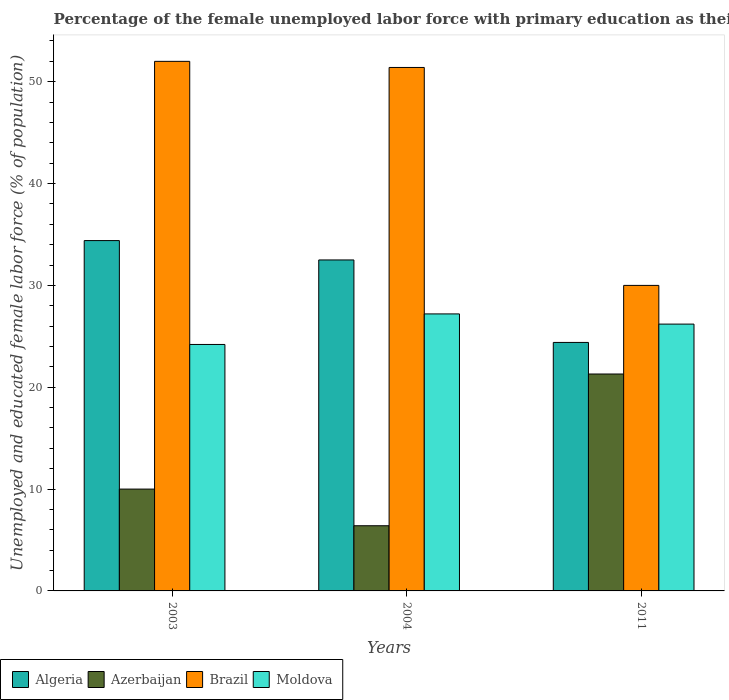How many different coloured bars are there?
Offer a terse response. 4. How many groups of bars are there?
Keep it short and to the point. 3. Are the number of bars on each tick of the X-axis equal?
Keep it short and to the point. Yes. How many bars are there on the 3rd tick from the left?
Your answer should be compact. 4. How many bars are there on the 1st tick from the right?
Provide a succinct answer. 4. What is the percentage of the unemployed female labor force with primary education in Algeria in 2004?
Keep it short and to the point. 32.5. Across all years, what is the maximum percentage of the unemployed female labor force with primary education in Moldova?
Your answer should be compact. 27.2. Across all years, what is the minimum percentage of the unemployed female labor force with primary education in Azerbaijan?
Provide a succinct answer. 6.4. What is the total percentage of the unemployed female labor force with primary education in Algeria in the graph?
Your answer should be compact. 91.3. What is the difference between the percentage of the unemployed female labor force with primary education in Brazil in 2004 and that in 2011?
Offer a very short reply. 21.4. What is the difference between the percentage of the unemployed female labor force with primary education in Brazil in 2003 and the percentage of the unemployed female labor force with primary education in Azerbaijan in 2004?
Provide a short and direct response. 45.6. What is the average percentage of the unemployed female labor force with primary education in Brazil per year?
Give a very brief answer. 44.47. In the year 2004, what is the difference between the percentage of the unemployed female labor force with primary education in Brazil and percentage of the unemployed female labor force with primary education in Algeria?
Your response must be concise. 18.9. In how many years, is the percentage of the unemployed female labor force with primary education in Azerbaijan greater than 2 %?
Your response must be concise. 3. What is the ratio of the percentage of the unemployed female labor force with primary education in Brazil in 2003 to that in 2011?
Provide a succinct answer. 1.73. What is the difference between the highest and the lowest percentage of the unemployed female labor force with primary education in Algeria?
Make the answer very short. 10. Is the sum of the percentage of the unemployed female labor force with primary education in Algeria in 2004 and 2011 greater than the maximum percentage of the unemployed female labor force with primary education in Brazil across all years?
Provide a short and direct response. Yes. What does the 4th bar from the left in 2011 represents?
Your answer should be very brief. Moldova. What does the 3rd bar from the right in 2004 represents?
Your answer should be compact. Azerbaijan. Is it the case that in every year, the sum of the percentage of the unemployed female labor force with primary education in Azerbaijan and percentage of the unemployed female labor force with primary education in Brazil is greater than the percentage of the unemployed female labor force with primary education in Algeria?
Ensure brevity in your answer.  Yes. Are the values on the major ticks of Y-axis written in scientific E-notation?
Keep it short and to the point. No. Does the graph contain any zero values?
Provide a succinct answer. No. Does the graph contain grids?
Offer a terse response. No. What is the title of the graph?
Provide a short and direct response. Percentage of the female unemployed labor force with primary education as their highest grade. Does "Haiti" appear as one of the legend labels in the graph?
Provide a short and direct response. No. What is the label or title of the X-axis?
Give a very brief answer. Years. What is the label or title of the Y-axis?
Your answer should be compact. Unemployed and educated female labor force (% of population). What is the Unemployed and educated female labor force (% of population) of Algeria in 2003?
Offer a very short reply. 34.4. What is the Unemployed and educated female labor force (% of population) of Azerbaijan in 2003?
Your answer should be very brief. 10. What is the Unemployed and educated female labor force (% of population) in Moldova in 2003?
Offer a terse response. 24.2. What is the Unemployed and educated female labor force (% of population) of Algeria in 2004?
Your response must be concise. 32.5. What is the Unemployed and educated female labor force (% of population) in Azerbaijan in 2004?
Offer a very short reply. 6.4. What is the Unemployed and educated female labor force (% of population) in Brazil in 2004?
Your response must be concise. 51.4. What is the Unemployed and educated female labor force (% of population) in Moldova in 2004?
Your answer should be very brief. 27.2. What is the Unemployed and educated female labor force (% of population) of Algeria in 2011?
Your answer should be compact. 24.4. What is the Unemployed and educated female labor force (% of population) of Azerbaijan in 2011?
Offer a terse response. 21.3. What is the Unemployed and educated female labor force (% of population) in Moldova in 2011?
Offer a terse response. 26.2. Across all years, what is the maximum Unemployed and educated female labor force (% of population) of Algeria?
Offer a very short reply. 34.4. Across all years, what is the maximum Unemployed and educated female labor force (% of population) of Azerbaijan?
Make the answer very short. 21.3. Across all years, what is the maximum Unemployed and educated female labor force (% of population) of Moldova?
Ensure brevity in your answer.  27.2. Across all years, what is the minimum Unemployed and educated female labor force (% of population) in Algeria?
Ensure brevity in your answer.  24.4. Across all years, what is the minimum Unemployed and educated female labor force (% of population) in Azerbaijan?
Provide a succinct answer. 6.4. Across all years, what is the minimum Unemployed and educated female labor force (% of population) of Moldova?
Keep it short and to the point. 24.2. What is the total Unemployed and educated female labor force (% of population) in Algeria in the graph?
Your answer should be compact. 91.3. What is the total Unemployed and educated female labor force (% of population) in Azerbaijan in the graph?
Ensure brevity in your answer.  37.7. What is the total Unemployed and educated female labor force (% of population) of Brazil in the graph?
Keep it short and to the point. 133.4. What is the total Unemployed and educated female labor force (% of population) in Moldova in the graph?
Give a very brief answer. 77.6. What is the difference between the Unemployed and educated female labor force (% of population) in Algeria in 2003 and that in 2004?
Your response must be concise. 1.9. What is the difference between the Unemployed and educated female labor force (% of population) in Azerbaijan in 2003 and that in 2004?
Your answer should be very brief. 3.6. What is the difference between the Unemployed and educated female labor force (% of population) in Moldova in 2003 and that in 2004?
Ensure brevity in your answer.  -3. What is the difference between the Unemployed and educated female labor force (% of population) of Algeria in 2003 and that in 2011?
Make the answer very short. 10. What is the difference between the Unemployed and educated female labor force (% of population) of Moldova in 2003 and that in 2011?
Give a very brief answer. -2. What is the difference between the Unemployed and educated female labor force (% of population) in Azerbaijan in 2004 and that in 2011?
Make the answer very short. -14.9. What is the difference between the Unemployed and educated female labor force (% of population) in Brazil in 2004 and that in 2011?
Offer a terse response. 21.4. What is the difference between the Unemployed and educated female labor force (% of population) in Moldova in 2004 and that in 2011?
Your answer should be compact. 1. What is the difference between the Unemployed and educated female labor force (% of population) in Algeria in 2003 and the Unemployed and educated female labor force (% of population) in Brazil in 2004?
Give a very brief answer. -17. What is the difference between the Unemployed and educated female labor force (% of population) in Algeria in 2003 and the Unemployed and educated female labor force (% of population) in Moldova in 2004?
Provide a succinct answer. 7.2. What is the difference between the Unemployed and educated female labor force (% of population) of Azerbaijan in 2003 and the Unemployed and educated female labor force (% of population) of Brazil in 2004?
Keep it short and to the point. -41.4. What is the difference between the Unemployed and educated female labor force (% of population) in Azerbaijan in 2003 and the Unemployed and educated female labor force (% of population) in Moldova in 2004?
Provide a succinct answer. -17.2. What is the difference between the Unemployed and educated female labor force (% of population) in Brazil in 2003 and the Unemployed and educated female labor force (% of population) in Moldova in 2004?
Provide a succinct answer. 24.8. What is the difference between the Unemployed and educated female labor force (% of population) in Algeria in 2003 and the Unemployed and educated female labor force (% of population) in Moldova in 2011?
Make the answer very short. 8.2. What is the difference between the Unemployed and educated female labor force (% of population) in Azerbaijan in 2003 and the Unemployed and educated female labor force (% of population) in Moldova in 2011?
Your answer should be very brief. -16.2. What is the difference between the Unemployed and educated female labor force (% of population) in Brazil in 2003 and the Unemployed and educated female labor force (% of population) in Moldova in 2011?
Your answer should be very brief. 25.8. What is the difference between the Unemployed and educated female labor force (% of population) of Algeria in 2004 and the Unemployed and educated female labor force (% of population) of Brazil in 2011?
Your answer should be compact. 2.5. What is the difference between the Unemployed and educated female labor force (% of population) in Algeria in 2004 and the Unemployed and educated female labor force (% of population) in Moldova in 2011?
Offer a terse response. 6.3. What is the difference between the Unemployed and educated female labor force (% of population) of Azerbaijan in 2004 and the Unemployed and educated female labor force (% of population) of Brazil in 2011?
Ensure brevity in your answer.  -23.6. What is the difference between the Unemployed and educated female labor force (% of population) of Azerbaijan in 2004 and the Unemployed and educated female labor force (% of population) of Moldova in 2011?
Provide a short and direct response. -19.8. What is the difference between the Unemployed and educated female labor force (% of population) of Brazil in 2004 and the Unemployed and educated female labor force (% of population) of Moldova in 2011?
Offer a very short reply. 25.2. What is the average Unemployed and educated female labor force (% of population) in Algeria per year?
Provide a succinct answer. 30.43. What is the average Unemployed and educated female labor force (% of population) in Azerbaijan per year?
Offer a very short reply. 12.57. What is the average Unemployed and educated female labor force (% of population) in Brazil per year?
Your answer should be compact. 44.47. What is the average Unemployed and educated female labor force (% of population) of Moldova per year?
Provide a short and direct response. 25.87. In the year 2003, what is the difference between the Unemployed and educated female labor force (% of population) in Algeria and Unemployed and educated female labor force (% of population) in Azerbaijan?
Give a very brief answer. 24.4. In the year 2003, what is the difference between the Unemployed and educated female labor force (% of population) of Algeria and Unemployed and educated female labor force (% of population) of Brazil?
Your answer should be very brief. -17.6. In the year 2003, what is the difference between the Unemployed and educated female labor force (% of population) of Azerbaijan and Unemployed and educated female labor force (% of population) of Brazil?
Keep it short and to the point. -42. In the year 2003, what is the difference between the Unemployed and educated female labor force (% of population) in Azerbaijan and Unemployed and educated female labor force (% of population) in Moldova?
Ensure brevity in your answer.  -14.2. In the year 2003, what is the difference between the Unemployed and educated female labor force (% of population) in Brazil and Unemployed and educated female labor force (% of population) in Moldova?
Offer a terse response. 27.8. In the year 2004, what is the difference between the Unemployed and educated female labor force (% of population) of Algeria and Unemployed and educated female labor force (% of population) of Azerbaijan?
Your answer should be compact. 26.1. In the year 2004, what is the difference between the Unemployed and educated female labor force (% of population) in Algeria and Unemployed and educated female labor force (% of population) in Brazil?
Provide a short and direct response. -18.9. In the year 2004, what is the difference between the Unemployed and educated female labor force (% of population) of Algeria and Unemployed and educated female labor force (% of population) of Moldova?
Your response must be concise. 5.3. In the year 2004, what is the difference between the Unemployed and educated female labor force (% of population) in Azerbaijan and Unemployed and educated female labor force (% of population) in Brazil?
Provide a short and direct response. -45. In the year 2004, what is the difference between the Unemployed and educated female labor force (% of population) of Azerbaijan and Unemployed and educated female labor force (% of population) of Moldova?
Ensure brevity in your answer.  -20.8. In the year 2004, what is the difference between the Unemployed and educated female labor force (% of population) of Brazil and Unemployed and educated female labor force (% of population) of Moldova?
Your answer should be compact. 24.2. In the year 2011, what is the difference between the Unemployed and educated female labor force (% of population) of Algeria and Unemployed and educated female labor force (% of population) of Brazil?
Ensure brevity in your answer.  -5.6. In the year 2011, what is the difference between the Unemployed and educated female labor force (% of population) of Algeria and Unemployed and educated female labor force (% of population) of Moldova?
Offer a very short reply. -1.8. In the year 2011, what is the difference between the Unemployed and educated female labor force (% of population) in Azerbaijan and Unemployed and educated female labor force (% of population) in Moldova?
Offer a terse response. -4.9. What is the ratio of the Unemployed and educated female labor force (% of population) of Algeria in 2003 to that in 2004?
Ensure brevity in your answer.  1.06. What is the ratio of the Unemployed and educated female labor force (% of population) in Azerbaijan in 2003 to that in 2004?
Your answer should be compact. 1.56. What is the ratio of the Unemployed and educated female labor force (% of population) of Brazil in 2003 to that in 2004?
Give a very brief answer. 1.01. What is the ratio of the Unemployed and educated female labor force (% of population) of Moldova in 2003 to that in 2004?
Offer a terse response. 0.89. What is the ratio of the Unemployed and educated female labor force (% of population) in Algeria in 2003 to that in 2011?
Provide a succinct answer. 1.41. What is the ratio of the Unemployed and educated female labor force (% of population) of Azerbaijan in 2003 to that in 2011?
Keep it short and to the point. 0.47. What is the ratio of the Unemployed and educated female labor force (% of population) of Brazil in 2003 to that in 2011?
Keep it short and to the point. 1.73. What is the ratio of the Unemployed and educated female labor force (% of population) in Moldova in 2003 to that in 2011?
Your response must be concise. 0.92. What is the ratio of the Unemployed and educated female labor force (% of population) in Algeria in 2004 to that in 2011?
Your response must be concise. 1.33. What is the ratio of the Unemployed and educated female labor force (% of population) of Azerbaijan in 2004 to that in 2011?
Keep it short and to the point. 0.3. What is the ratio of the Unemployed and educated female labor force (% of population) in Brazil in 2004 to that in 2011?
Offer a terse response. 1.71. What is the ratio of the Unemployed and educated female labor force (% of population) of Moldova in 2004 to that in 2011?
Give a very brief answer. 1.04. What is the difference between the highest and the second highest Unemployed and educated female labor force (% of population) in Azerbaijan?
Your response must be concise. 11.3. What is the difference between the highest and the second highest Unemployed and educated female labor force (% of population) of Brazil?
Make the answer very short. 0.6. What is the difference between the highest and the second highest Unemployed and educated female labor force (% of population) in Moldova?
Your answer should be compact. 1. What is the difference between the highest and the lowest Unemployed and educated female labor force (% of population) in Algeria?
Your answer should be compact. 10. 